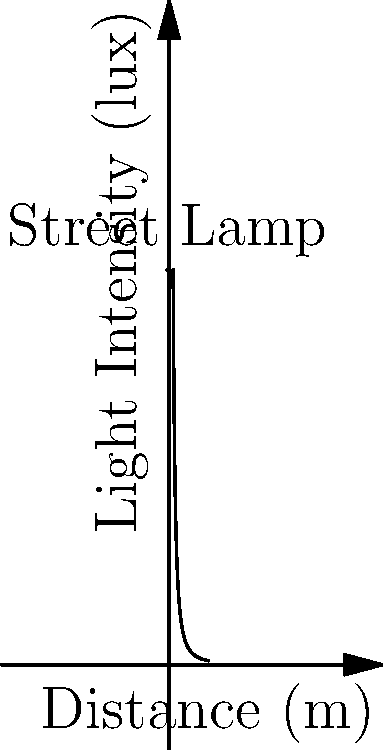As a software engineer developing a neighborhood watch application, you need to model the light intensity from street lamps. Given that the intensity of light follows an inverse square law, and a street lamp has an intensity of 100 lux at 1 meter, calculate the light intensity at 5 meters. How would this information be useful in your application? To solve this problem, we'll use the inverse square law for light intensity:

1) The inverse square law states that the intensity of light is inversely proportional to the square of the distance from the source. It can be expressed as:

   $$I_2 = I_1 \times (\frac{d_1}{d_2})^2$$

   Where $I_1$ is the initial intensity, $d_1$ is the initial distance, $I_2$ is the final intensity, and $d_2$ is the final distance.

2) We're given:
   $I_1 = 100$ lux (intensity at 1 meter)
   $d_1 = 1$ meter
   $d_2 = 5$ meters

3) Plugging these values into the equation:

   $$I_2 = 100 \times (\frac{1}{5})^2$$

4) Simplify:
   $$I_2 = 100 \times \frac{1}{25} = 4$$

5) Therefore, the light intensity at 5 meters is 4 lux.

This information would be useful in a neighborhood watch application to:
- Map areas of sufficient lighting for safety
- Identify potential "dark spots" that might need additional lighting
- Optimize patrol routes based on visibility
- Provide residents with information about well-lit areas for nighttime activities
Answer: 4 lux 